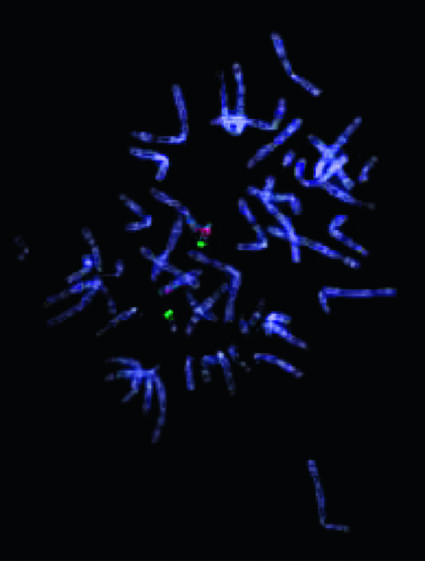what does one of the two chromosomes for 22q11 .2 not stain with?
Answer the question using a single word or phrase. The probe for 22q112 